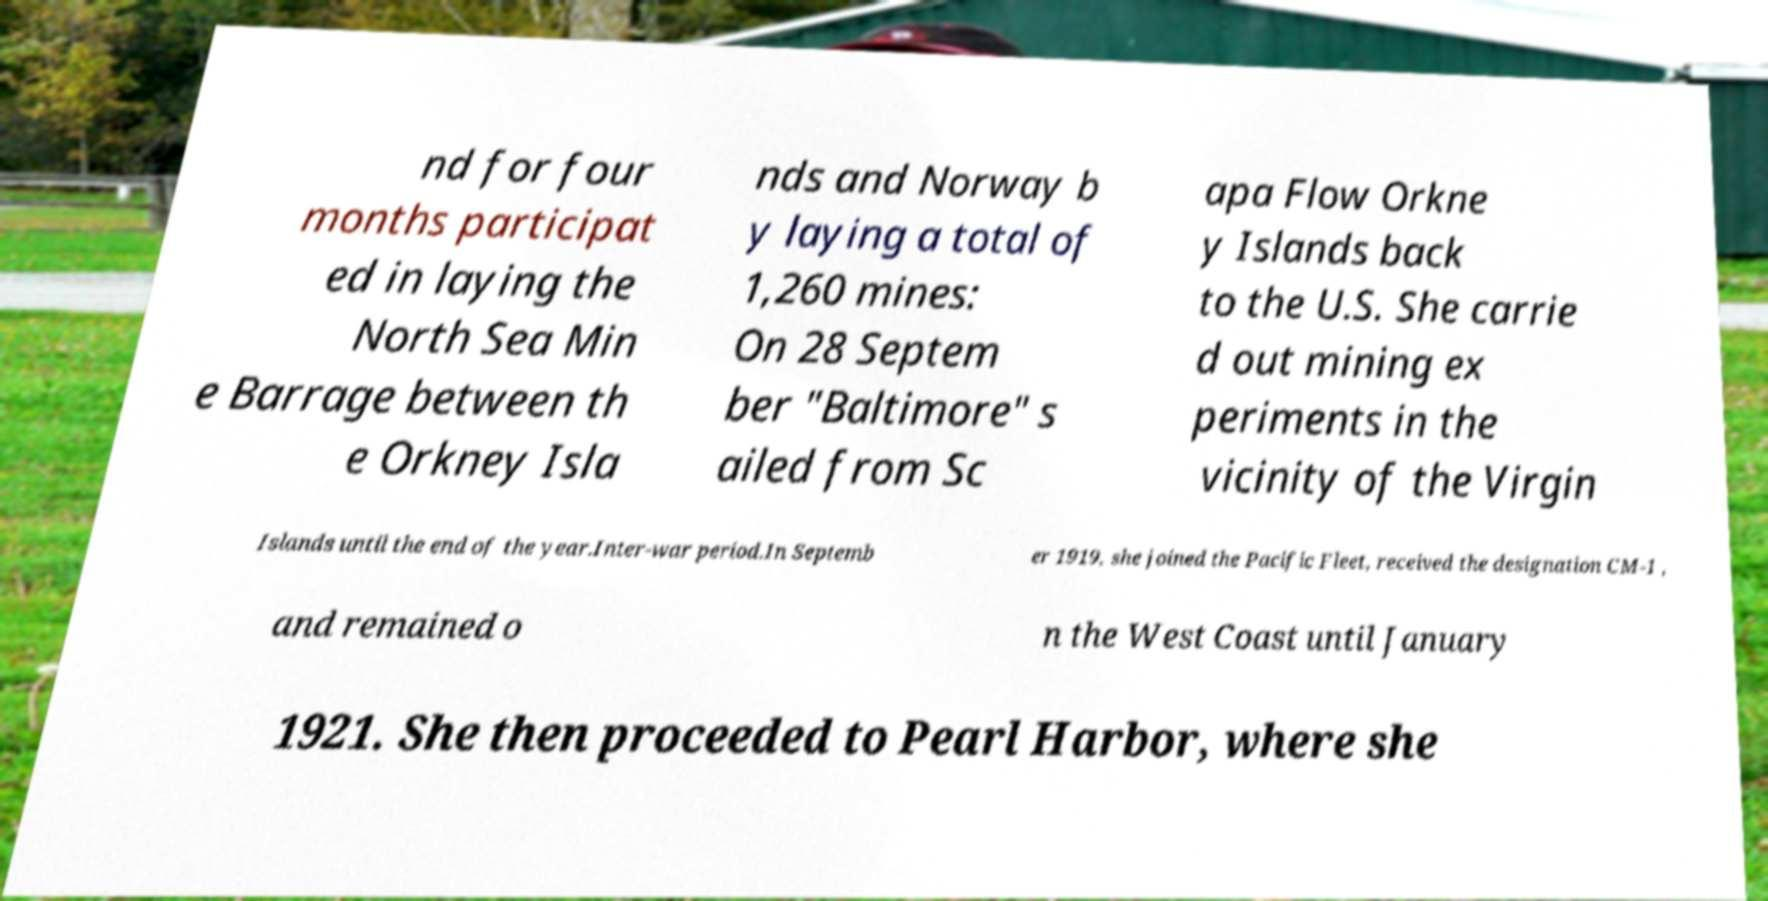I need the written content from this picture converted into text. Can you do that? nd for four months participat ed in laying the North Sea Min e Barrage between th e Orkney Isla nds and Norway b y laying a total of 1,260 mines: On 28 Septem ber "Baltimore" s ailed from Sc apa Flow Orkne y Islands back to the U.S. She carrie d out mining ex periments in the vicinity of the Virgin Islands until the end of the year.Inter-war period.In Septemb er 1919, she joined the Pacific Fleet, received the designation CM-1 , and remained o n the West Coast until January 1921. She then proceeded to Pearl Harbor, where she 